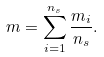Convert formula to latex. <formula><loc_0><loc_0><loc_500><loc_500>m = \sum _ { i = 1 } ^ { n _ { s } } \frac { m _ { i } } { n _ { s } } .</formula> 